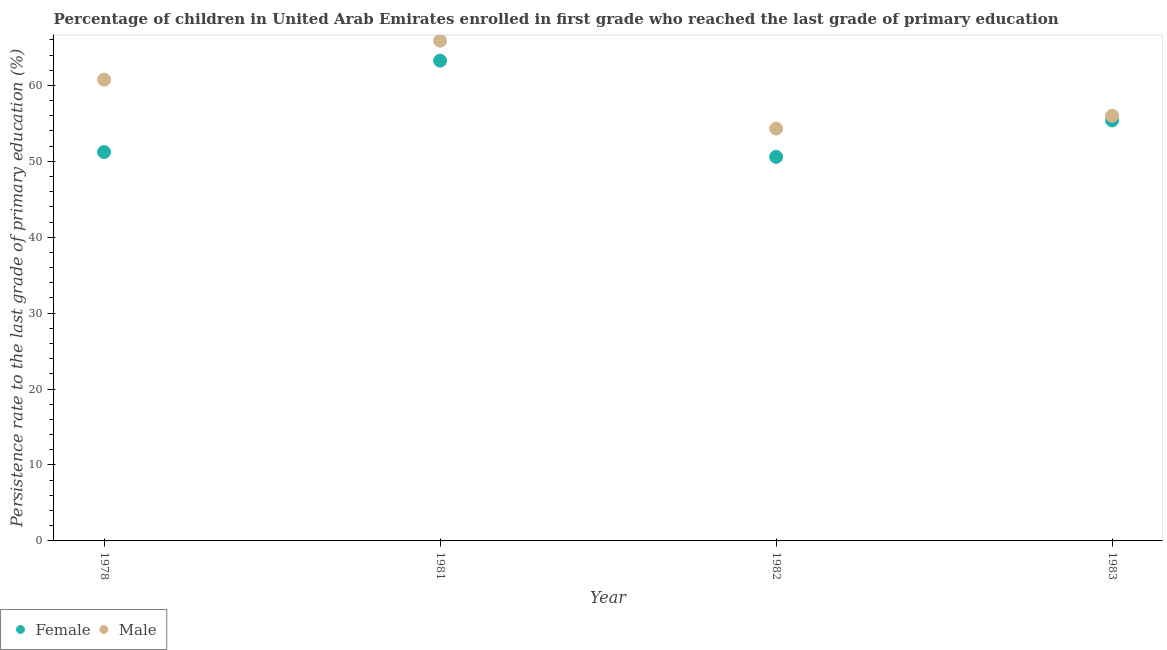How many different coloured dotlines are there?
Your answer should be very brief. 2. Is the number of dotlines equal to the number of legend labels?
Provide a short and direct response. Yes. What is the persistence rate of male students in 1982?
Give a very brief answer. 54.31. Across all years, what is the maximum persistence rate of male students?
Offer a very short reply. 65.89. Across all years, what is the minimum persistence rate of male students?
Your answer should be very brief. 54.31. In which year was the persistence rate of female students minimum?
Provide a succinct answer. 1982. What is the total persistence rate of female students in the graph?
Give a very brief answer. 220.44. What is the difference between the persistence rate of male students in 1978 and that in 1982?
Your answer should be very brief. 6.45. What is the difference between the persistence rate of male students in 1982 and the persistence rate of female students in 1981?
Provide a succinct answer. -8.95. What is the average persistence rate of female students per year?
Offer a terse response. 55.11. In the year 1983, what is the difference between the persistence rate of male students and persistence rate of female students?
Provide a short and direct response. 0.61. In how many years, is the persistence rate of male students greater than 26 %?
Your response must be concise. 4. What is the ratio of the persistence rate of female students in 1978 to that in 1981?
Make the answer very short. 0.81. Is the difference between the persistence rate of male students in 1982 and 1983 greater than the difference between the persistence rate of female students in 1982 and 1983?
Keep it short and to the point. Yes. What is the difference between the highest and the second highest persistence rate of female students?
Provide a short and direct response. 7.87. What is the difference between the highest and the lowest persistence rate of female students?
Your answer should be very brief. 12.67. Is the sum of the persistence rate of female students in 1981 and 1982 greater than the maximum persistence rate of male students across all years?
Make the answer very short. Yes. Is the persistence rate of male students strictly less than the persistence rate of female students over the years?
Ensure brevity in your answer.  No. What is the difference between two consecutive major ticks on the Y-axis?
Your response must be concise. 10. Does the graph contain any zero values?
Your response must be concise. No. Where does the legend appear in the graph?
Provide a succinct answer. Bottom left. How many legend labels are there?
Keep it short and to the point. 2. What is the title of the graph?
Provide a succinct answer. Percentage of children in United Arab Emirates enrolled in first grade who reached the last grade of primary education. What is the label or title of the X-axis?
Provide a short and direct response. Year. What is the label or title of the Y-axis?
Your response must be concise. Persistence rate to the last grade of primary education (%). What is the Persistence rate to the last grade of primary education (%) of Female in 1978?
Your response must be concise. 51.21. What is the Persistence rate to the last grade of primary education (%) of Male in 1978?
Provide a short and direct response. 60.76. What is the Persistence rate to the last grade of primary education (%) of Female in 1981?
Your answer should be compact. 63.25. What is the Persistence rate to the last grade of primary education (%) in Male in 1981?
Ensure brevity in your answer.  65.89. What is the Persistence rate to the last grade of primary education (%) in Female in 1982?
Offer a terse response. 50.58. What is the Persistence rate to the last grade of primary education (%) in Male in 1982?
Give a very brief answer. 54.31. What is the Persistence rate to the last grade of primary education (%) in Female in 1983?
Make the answer very short. 55.39. What is the Persistence rate to the last grade of primary education (%) in Male in 1983?
Provide a short and direct response. 56. Across all years, what is the maximum Persistence rate to the last grade of primary education (%) in Female?
Offer a very short reply. 63.25. Across all years, what is the maximum Persistence rate to the last grade of primary education (%) of Male?
Provide a short and direct response. 65.89. Across all years, what is the minimum Persistence rate to the last grade of primary education (%) of Female?
Your answer should be compact. 50.58. Across all years, what is the minimum Persistence rate to the last grade of primary education (%) in Male?
Make the answer very short. 54.31. What is the total Persistence rate to the last grade of primary education (%) in Female in the graph?
Your answer should be very brief. 220.44. What is the total Persistence rate to the last grade of primary education (%) in Male in the graph?
Keep it short and to the point. 236.95. What is the difference between the Persistence rate to the last grade of primary education (%) in Female in 1978 and that in 1981?
Provide a succinct answer. -12.04. What is the difference between the Persistence rate to the last grade of primary education (%) of Male in 1978 and that in 1981?
Give a very brief answer. -5.13. What is the difference between the Persistence rate to the last grade of primary education (%) of Female in 1978 and that in 1982?
Provide a short and direct response. 0.63. What is the difference between the Persistence rate to the last grade of primary education (%) of Male in 1978 and that in 1982?
Your answer should be very brief. 6.45. What is the difference between the Persistence rate to the last grade of primary education (%) in Female in 1978 and that in 1983?
Provide a succinct answer. -4.17. What is the difference between the Persistence rate to the last grade of primary education (%) of Male in 1978 and that in 1983?
Your answer should be very brief. 4.76. What is the difference between the Persistence rate to the last grade of primary education (%) in Female in 1981 and that in 1982?
Give a very brief answer. 12.67. What is the difference between the Persistence rate to the last grade of primary education (%) of Male in 1981 and that in 1982?
Make the answer very short. 11.58. What is the difference between the Persistence rate to the last grade of primary education (%) of Female in 1981 and that in 1983?
Provide a short and direct response. 7.87. What is the difference between the Persistence rate to the last grade of primary education (%) of Male in 1981 and that in 1983?
Your answer should be very brief. 9.89. What is the difference between the Persistence rate to the last grade of primary education (%) in Female in 1982 and that in 1983?
Provide a succinct answer. -4.8. What is the difference between the Persistence rate to the last grade of primary education (%) in Male in 1982 and that in 1983?
Your answer should be very brief. -1.69. What is the difference between the Persistence rate to the last grade of primary education (%) in Female in 1978 and the Persistence rate to the last grade of primary education (%) in Male in 1981?
Your response must be concise. -14.67. What is the difference between the Persistence rate to the last grade of primary education (%) of Female in 1978 and the Persistence rate to the last grade of primary education (%) of Male in 1982?
Offer a terse response. -3.09. What is the difference between the Persistence rate to the last grade of primary education (%) in Female in 1978 and the Persistence rate to the last grade of primary education (%) in Male in 1983?
Provide a short and direct response. -4.79. What is the difference between the Persistence rate to the last grade of primary education (%) of Female in 1981 and the Persistence rate to the last grade of primary education (%) of Male in 1982?
Your answer should be compact. 8.95. What is the difference between the Persistence rate to the last grade of primary education (%) in Female in 1981 and the Persistence rate to the last grade of primary education (%) in Male in 1983?
Your response must be concise. 7.25. What is the difference between the Persistence rate to the last grade of primary education (%) of Female in 1982 and the Persistence rate to the last grade of primary education (%) of Male in 1983?
Provide a short and direct response. -5.41. What is the average Persistence rate to the last grade of primary education (%) of Female per year?
Your answer should be very brief. 55.11. What is the average Persistence rate to the last grade of primary education (%) in Male per year?
Offer a terse response. 59.24. In the year 1978, what is the difference between the Persistence rate to the last grade of primary education (%) of Female and Persistence rate to the last grade of primary education (%) of Male?
Give a very brief answer. -9.54. In the year 1981, what is the difference between the Persistence rate to the last grade of primary education (%) of Female and Persistence rate to the last grade of primary education (%) of Male?
Offer a terse response. -2.63. In the year 1982, what is the difference between the Persistence rate to the last grade of primary education (%) of Female and Persistence rate to the last grade of primary education (%) of Male?
Make the answer very short. -3.72. In the year 1983, what is the difference between the Persistence rate to the last grade of primary education (%) of Female and Persistence rate to the last grade of primary education (%) of Male?
Your answer should be compact. -0.61. What is the ratio of the Persistence rate to the last grade of primary education (%) in Female in 1978 to that in 1981?
Offer a terse response. 0.81. What is the ratio of the Persistence rate to the last grade of primary education (%) in Male in 1978 to that in 1981?
Your answer should be compact. 0.92. What is the ratio of the Persistence rate to the last grade of primary education (%) of Female in 1978 to that in 1982?
Provide a short and direct response. 1.01. What is the ratio of the Persistence rate to the last grade of primary education (%) of Male in 1978 to that in 1982?
Provide a succinct answer. 1.12. What is the ratio of the Persistence rate to the last grade of primary education (%) in Female in 1978 to that in 1983?
Your answer should be very brief. 0.92. What is the ratio of the Persistence rate to the last grade of primary education (%) in Male in 1978 to that in 1983?
Your answer should be very brief. 1.08. What is the ratio of the Persistence rate to the last grade of primary education (%) of Female in 1981 to that in 1982?
Give a very brief answer. 1.25. What is the ratio of the Persistence rate to the last grade of primary education (%) of Male in 1981 to that in 1982?
Offer a terse response. 1.21. What is the ratio of the Persistence rate to the last grade of primary education (%) in Female in 1981 to that in 1983?
Provide a succinct answer. 1.14. What is the ratio of the Persistence rate to the last grade of primary education (%) in Male in 1981 to that in 1983?
Offer a terse response. 1.18. What is the ratio of the Persistence rate to the last grade of primary education (%) of Female in 1982 to that in 1983?
Your answer should be compact. 0.91. What is the ratio of the Persistence rate to the last grade of primary education (%) of Male in 1982 to that in 1983?
Offer a terse response. 0.97. What is the difference between the highest and the second highest Persistence rate to the last grade of primary education (%) of Female?
Keep it short and to the point. 7.87. What is the difference between the highest and the second highest Persistence rate to the last grade of primary education (%) in Male?
Keep it short and to the point. 5.13. What is the difference between the highest and the lowest Persistence rate to the last grade of primary education (%) of Female?
Offer a terse response. 12.67. What is the difference between the highest and the lowest Persistence rate to the last grade of primary education (%) of Male?
Offer a terse response. 11.58. 